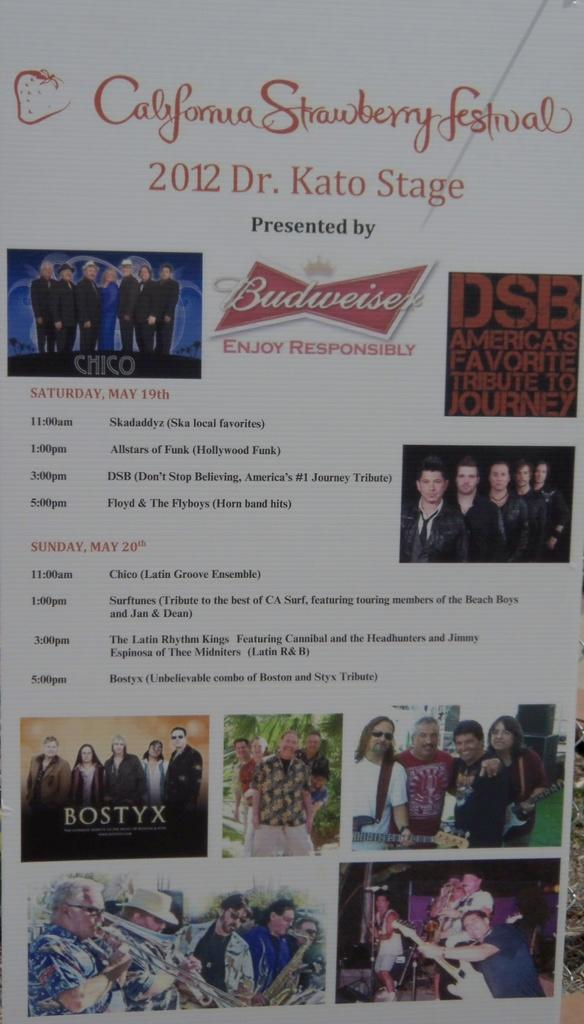<image>
Present a compact description of the photo's key features. The California Strawberry festival is sponsored by Budweiser. 